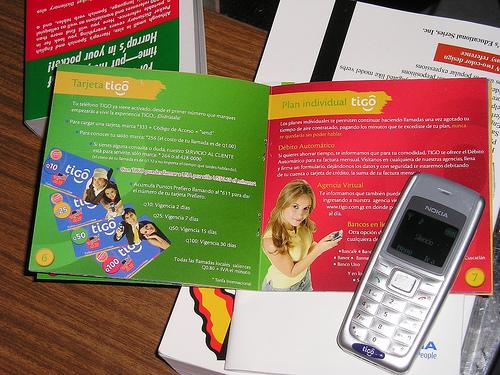What color is the cell phone?
Quick response, please. Silver. What brand is the phone?
Answer briefly. Nokia. Are these instructions for a cell phone?
Write a very short answer. Yes. Is there a smartphone here?
Short answer required. No. 